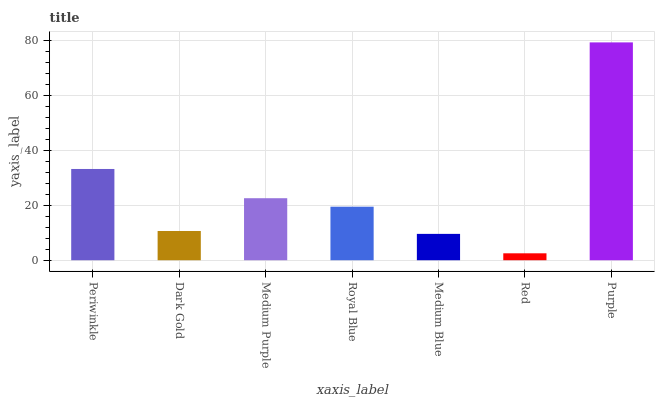Is Red the minimum?
Answer yes or no. Yes. Is Purple the maximum?
Answer yes or no. Yes. Is Dark Gold the minimum?
Answer yes or no. No. Is Dark Gold the maximum?
Answer yes or no. No. Is Periwinkle greater than Dark Gold?
Answer yes or no. Yes. Is Dark Gold less than Periwinkle?
Answer yes or no. Yes. Is Dark Gold greater than Periwinkle?
Answer yes or no. No. Is Periwinkle less than Dark Gold?
Answer yes or no. No. Is Royal Blue the high median?
Answer yes or no. Yes. Is Royal Blue the low median?
Answer yes or no. Yes. Is Dark Gold the high median?
Answer yes or no. No. Is Dark Gold the low median?
Answer yes or no. No. 